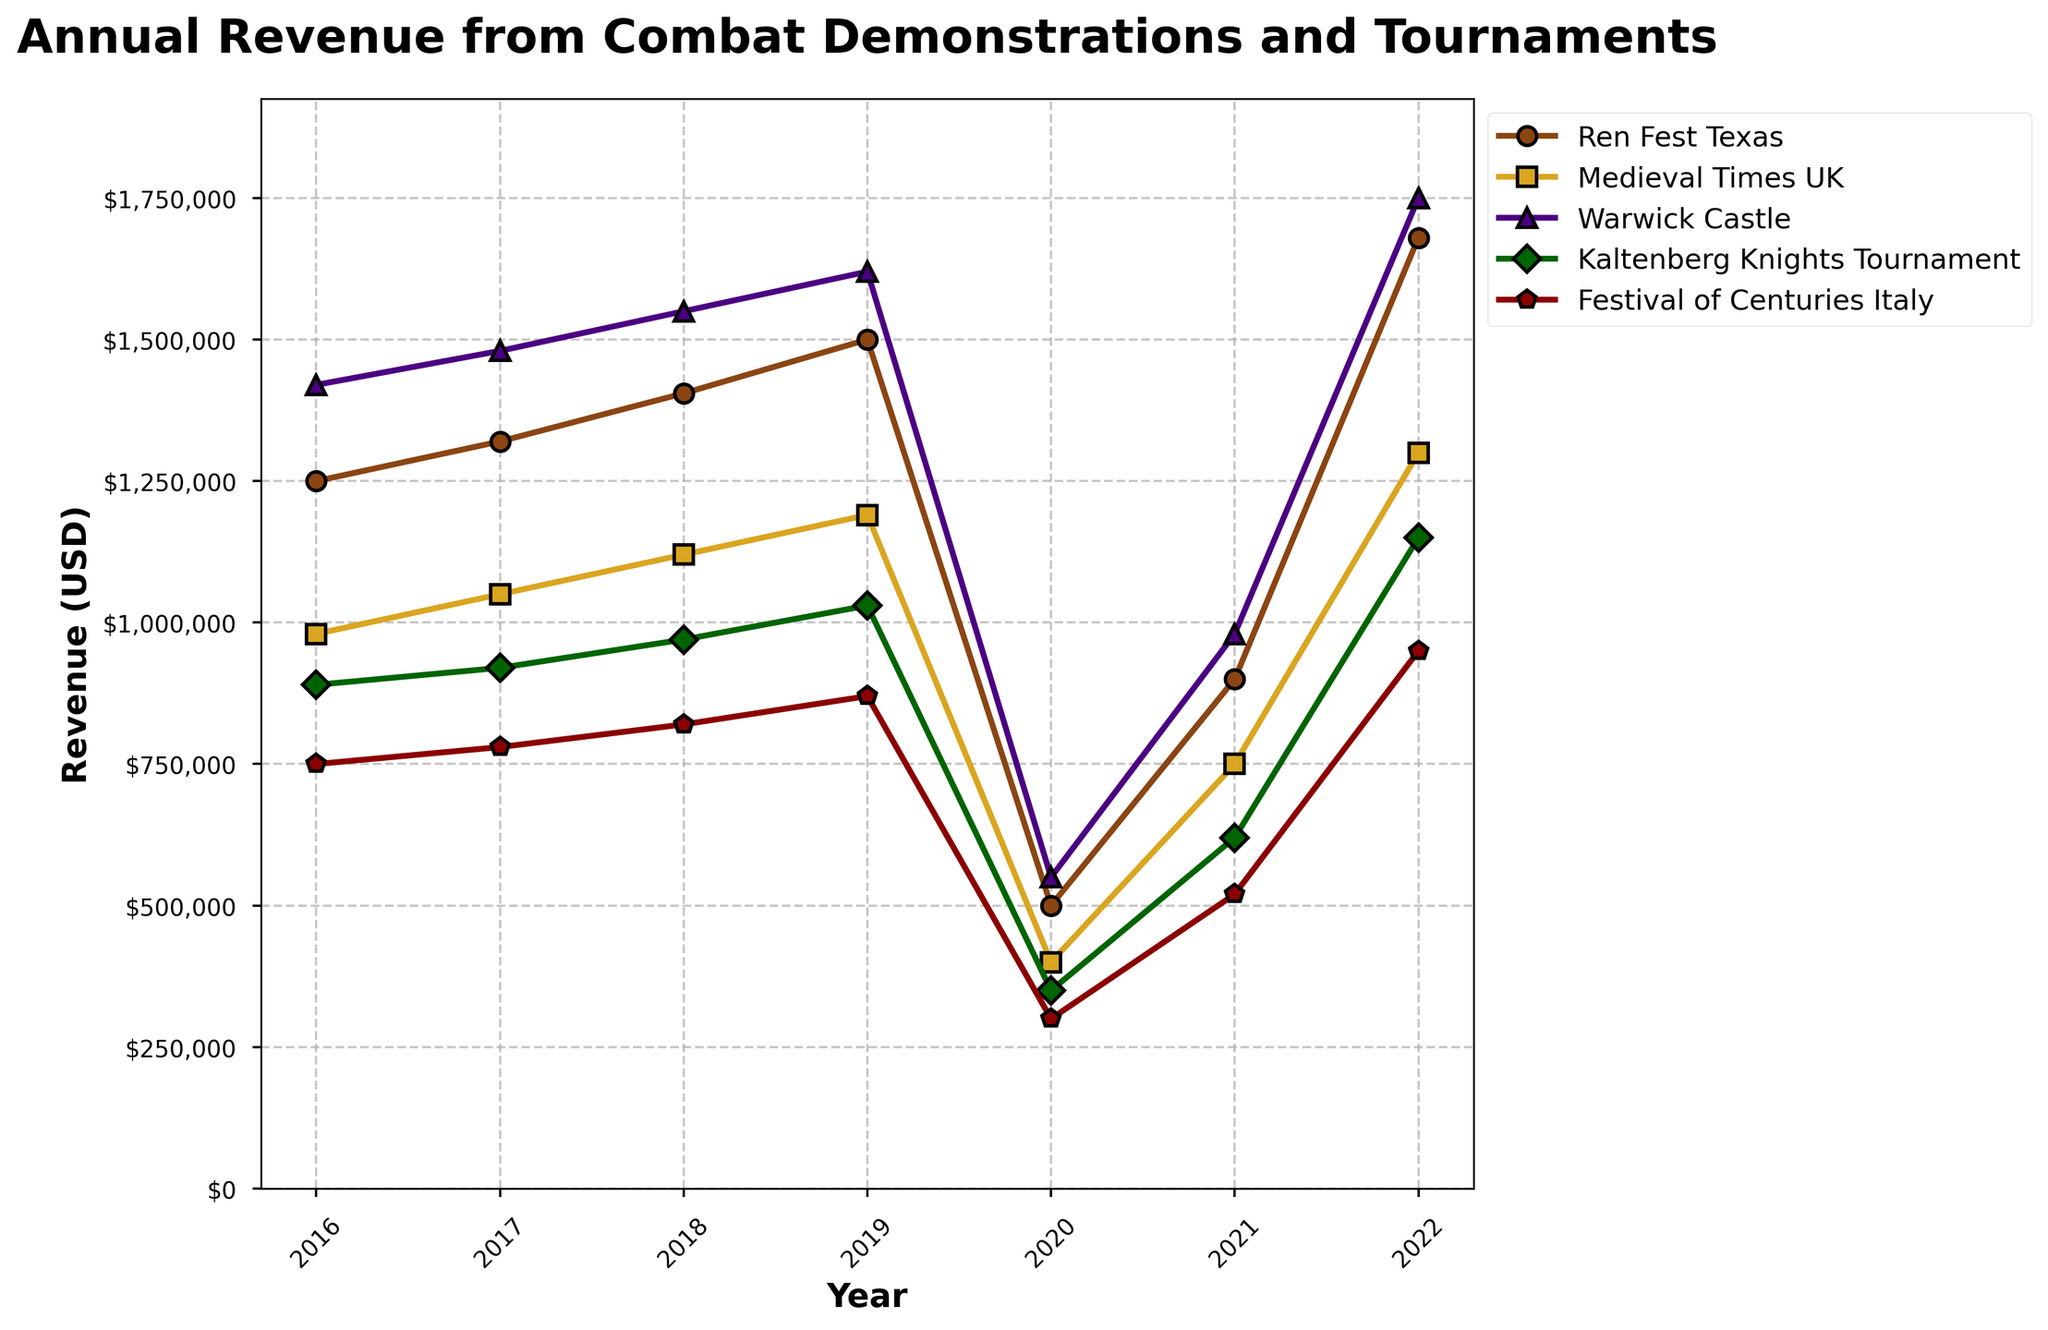Which fair had the highest revenue in 2022? By looking at the endpoint of the lines for 2022, identify which line reaches the highest level on the y-axis.
Answer: Warwick Castle How did the revenue of Ren Fest Texas change from 2020 to 2022? Look at the line for Ren Fest Texas and compare the y-axis values between the years 2020 and 2022. The revenue increased from $500,000 in 2020 to $1,680,000 in 2022.
Answer: Increased by $1,180,000 What was the combined revenue of Medieval Times UK and Kaltenberg Knights Tournament in 2021? Look at the values for Medieval Times UK and Kaltenberg Knights Tournament in 2021, which are $750,000 and $620,000 respectively. Add these two values. $750,000 + $620,000
Answer: $1,370,000 During which year did Festival of Centuries Italy experience the highest revenue growth compared to the previous year? Calculate the yearly revenue difference for Festival of Centuries Italy and determine which year had the largest increase. The largest growth was from 2021 to 2022.
Answer: 2022 Which fair showed the smallest revenue drop in 2020 compared to 2019? Calculate the revenue drop for each fair from 2019 to 2020 and identify the smallest drop. Ren Fest Texas dropped from $1,500,000 to $500,000, Medieval Times UK from $1,190,000 to $400,000, Warwick Castle from $1,620,000 to $550,000, Kaltenberg Knights Tournament from $1,030,000 to $350,000, and Festival of Centuries Italy from $870,000 to $300,000. The smallest drop is for Warwick Castle at $1,070,000.
Answer: Warwick Castle What was the trend for Kaltenberg Knights Tournament revenue from 2016 to 2022? Trace the line representing Kaltenberg Knights Tournament and observe the changes in height along the y-axis from 2016 to 2022. Overall, the revenue showed an increasing trend from 2016 to 2019, dropped significantly in 2020, and then recovered but did not reach the 2019 level by 2022.
Answer: Increase, decrease, recovery How did the revenue of Warwick Castle in 2020 compare to its revenue in 2017? Compare the y-axis values for Warwick Castle in the years 2017 and 2020. In 2017, it is $1,480,000; in 2020, it is $550,000.
Answer: Much lower in 2020 What is the average revenue of Warwick Castle from 2016 to 2019? Sum the revenues of Warwick Castle from 2016 to 2019 ($1,420,000 + $1,480,000 + $1,550,000 + $1,620,000) and divide by the number of years, which is 4.
Answer: $1,517,500 Which fair had the most consistent revenue growth from 2016 to 2019? Observe the lines and focus on which line has a steady upward slope without significant fluctuations between 2016 to 2019.
Answer: Ren Fest Texas In which year did all fairs experience a revenue drop? Check for the common year where the revenue line for each fair reduces compared to the previous year. This is noticeable in 2020.
Answer: 2020 